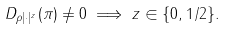<formula> <loc_0><loc_0><loc_500><loc_500>D _ { \rho | \cdot | ^ { z } } ( \pi ) \not = 0 \implies z \in \{ 0 , 1 / 2 \} .</formula> 